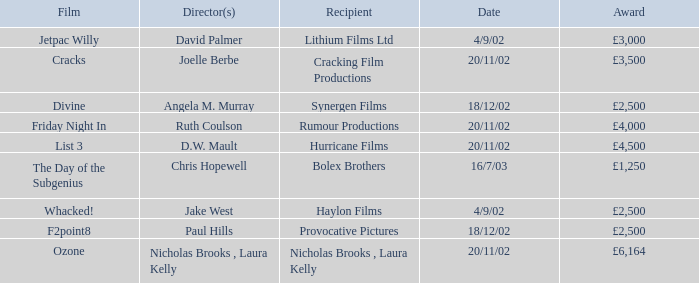What award did the film Ozone win? £6,164. 